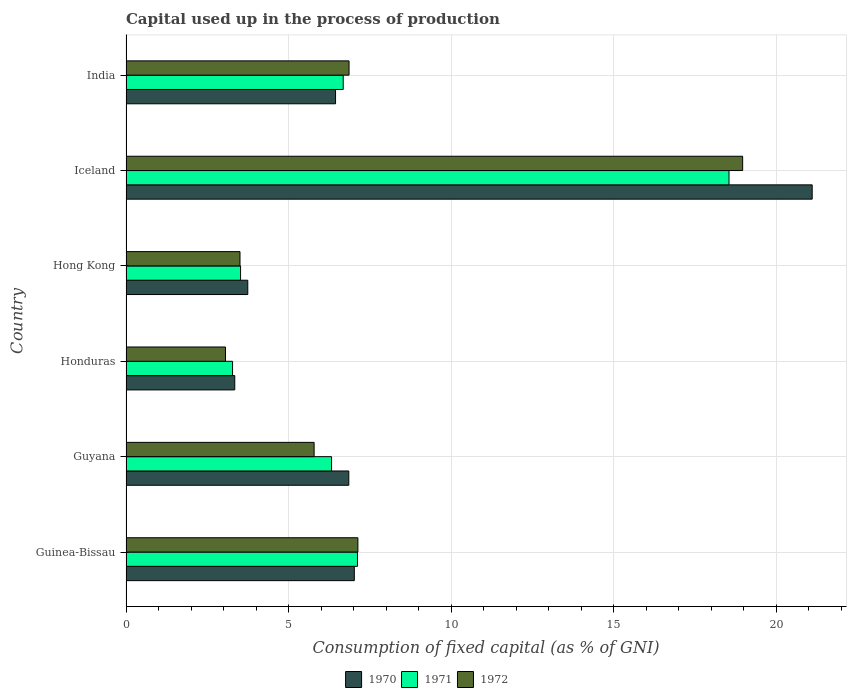How many different coloured bars are there?
Keep it short and to the point. 3. Are the number of bars per tick equal to the number of legend labels?
Keep it short and to the point. Yes. What is the label of the 1st group of bars from the top?
Ensure brevity in your answer.  India. In how many cases, is the number of bars for a given country not equal to the number of legend labels?
Make the answer very short. 0. What is the capital used up in the process of production in 1970 in Iceland?
Give a very brief answer. 21.11. Across all countries, what is the maximum capital used up in the process of production in 1972?
Provide a succinct answer. 18.97. Across all countries, what is the minimum capital used up in the process of production in 1971?
Ensure brevity in your answer.  3.28. In which country was the capital used up in the process of production in 1970 minimum?
Make the answer very short. Honduras. What is the total capital used up in the process of production in 1970 in the graph?
Ensure brevity in your answer.  48.53. What is the difference between the capital used up in the process of production in 1970 in Guyana and that in Honduras?
Provide a short and direct response. 3.51. What is the difference between the capital used up in the process of production in 1971 in Honduras and the capital used up in the process of production in 1970 in Guinea-Bissau?
Make the answer very short. -3.75. What is the average capital used up in the process of production in 1972 per country?
Provide a short and direct response. 7.55. What is the difference between the capital used up in the process of production in 1971 and capital used up in the process of production in 1970 in Guinea-Bissau?
Your answer should be very brief. 0.1. What is the ratio of the capital used up in the process of production in 1970 in Guyana to that in Iceland?
Ensure brevity in your answer.  0.32. What is the difference between the highest and the second highest capital used up in the process of production in 1972?
Keep it short and to the point. 11.84. What is the difference between the highest and the lowest capital used up in the process of production in 1972?
Make the answer very short. 15.91. In how many countries, is the capital used up in the process of production in 1971 greater than the average capital used up in the process of production in 1971 taken over all countries?
Your response must be concise. 1. Is the sum of the capital used up in the process of production in 1970 in Iceland and India greater than the maximum capital used up in the process of production in 1972 across all countries?
Your answer should be compact. Yes. What does the 3rd bar from the bottom in Hong Kong represents?
Provide a short and direct response. 1972. Is it the case that in every country, the sum of the capital used up in the process of production in 1970 and capital used up in the process of production in 1971 is greater than the capital used up in the process of production in 1972?
Keep it short and to the point. Yes. How many countries are there in the graph?
Your answer should be very brief. 6. Are the values on the major ticks of X-axis written in scientific E-notation?
Your answer should be compact. No. Does the graph contain grids?
Provide a succinct answer. Yes. How many legend labels are there?
Your response must be concise. 3. How are the legend labels stacked?
Provide a short and direct response. Horizontal. What is the title of the graph?
Keep it short and to the point. Capital used up in the process of production. Does "1966" appear as one of the legend labels in the graph?
Keep it short and to the point. No. What is the label or title of the X-axis?
Ensure brevity in your answer.  Consumption of fixed capital (as % of GNI). What is the label or title of the Y-axis?
Give a very brief answer. Country. What is the Consumption of fixed capital (as % of GNI) of 1970 in Guinea-Bissau?
Ensure brevity in your answer.  7.02. What is the Consumption of fixed capital (as % of GNI) in 1971 in Guinea-Bissau?
Offer a terse response. 7.12. What is the Consumption of fixed capital (as % of GNI) in 1972 in Guinea-Bissau?
Your answer should be very brief. 7.13. What is the Consumption of fixed capital (as % of GNI) of 1970 in Guyana?
Offer a terse response. 6.85. What is the Consumption of fixed capital (as % of GNI) of 1971 in Guyana?
Your answer should be very brief. 6.32. What is the Consumption of fixed capital (as % of GNI) of 1972 in Guyana?
Provide a short and direct response. 5.79. What is the Consumption of fixed capital (as % of GNI) in 1970 in Honduras?
Keep it short and to the point. 3.35. What is the Consumption of fixed capital (as % of GNI) of 1971 in Honduras?
Ensure brevity in your answer.  3.28. What is the Consumption of fixed capital (as % of GNI) of 1972 in Honduras?
Provide a succinct answer. 3.06. What is the Consumption of fixed capital (as % of GNI) in 1970 in Hong Kong?
Give a very brief answer. 3.75. What is the Consumption of fixed capital (as % of GNI) of 1971 in Hong Kong?
Provide a succinct answer. 3.52. What is the Consumption of fixed capital (as % of GNI) in 1972 in Hong Kong?
Offer a very short reply. 3.51. What is the Consumption of fixed capital (as % of GNI) of 1970 in Iceland?
Offer a terse response. 21.11. What is the Consumption of fixed capital (as % of GNI) in 1971 in Iceland?
Ensure brevity in your answer.  18.55. What is the Consumption of fixed capital (as % of GNI) in 1972 in Iceland?
Make the answer very short. 18.97. What is the Consumption of fixed capital (as % of GNI) in 1970 in India?
Give a very brief answer. 6.45. What is the Consumption of fixed capital (as % of GNI) of 1971 in India?
Ensure brevity in your answer.  6.68. What is the Consumption of fixed capital (as % of GNI) in 1972 in India?
Provide a succinct answer. 6.86. Across all countries, what is the maximum Consumption of fixed capital (as % of GNI) in 1970?
Make the answer very short. 21.11. Across all countries, what is the maximum Consumption of fixed capital (as % of GNI) of 1971?
Ensure brevity in your answer.  18.55. Across all countries, what is the maximum Consumption of fixed capital (as % of GNI) of 1972?
Your answer should be very brief. 18.97. Across all countries, what is the minimum Consumption of fixed capital (as % of GNI) in 1970?
Make the answer very short. 3.35. Across all countries, what is the minimum Consumption of fixed capital (as % of GNI) of 1971?
Make the answer very short. 3.28. Across all countries, what is the minimum Consumption of fixed capital (as % of GNI) of 1972?
Provide a succinct answer. 3.06. What is the total Consumption of fixed capital (as % of GNI) in 1970 in the graph?
Provide a short and direct response. 48.53. What is the total Consumption of fixed capital (as % of GNI) of 1971 in the graph?
Your answer should be very brief. 45.49. What is the total Consumption of fixed capital (as % of GNI) in 1972 in the graph?
Provide a short and direct response. 45.33. What is the difference between the Consumption of fixed capital (as % of GNI) of 1970 in Guinea-Bissau and that in Guyana?
Make the answer very short. 0.17. What is the difference between the Consumption of fixed capital (as % of GNI) in 1971 in Guinea-Bissau and that in Guyana?
Keep it short and to the point. 0.8. What is the difference between the Consumption of fixed capital (as % of GNI) of 1972 in Guinea-Bissau and that in Guyana?
Provide a succinct answer. 1.35. What is the difference between the Consumption of fixed capital (as % of GNI) of 1970 in Guinea-Bissau and that in Honduras?
Your answer should be very brief. 3.68. What is the difference between the Consumption of fixed capital (as % of GNI) of 1971 in Guinea-Bissau and that in Honduras?
Keep it short and to the point. 3.84. What is the difference between the Consumption of fixed capital (as % of GNI) of 1972 in Guinea-Bissau and that in Honduras?
Your answer should be compact. 4.07. What is the difference between the Consumption of fixed capital (as % of GNI) of 1970 in Guinea-Bissau and that in Hong Kong?
Ensure brevity in your answer.  3.28. What is the difference between the Consumption of fixed capital (as % of GNI) of 1971 in Guinea-Bissau and that in Hong Kong?
Your answer should be very brief. 3.6. What is the difference between the Consumption of fixed capital (as % of GNI) in 1972 in Guinea-Bissau and that in Hong Kong?
Give a very brief answer. 3.63. What is the difference between the Consumption of fixed capital (as % of GNI) in 1970 in Guinea-Bissau and that in Iceland?
Provide a succinct answer. -14.09. What is the difference between the Consumption of fixed capital (as % of GNI) in 1971 in Guinea-Bissau and that in Iceland?
Your answer should be compact. -11.43. What is the difference between the Consumption of fixed capital (as % of GNI) of 1972 in Guinea-Bissau and that in Iceland?
Give a very brief answer. -11.84. What is the difference between the Consumption of fixed capital (as % of GNI) of 1970 in Guinea-Bissau and that in India?
Offer a very short reply. 0.58. What is the difference between the Consumption of fixed capital (as % of GNI) of 1971 in Guinea-Bissau and that in India?
Offer a very short reply. 0.44. What is the difference between the Consumption of fixed capital (as % of GNI) in 1972 in Guinea-Bissau and that in India?
Your response must be concise. 0.27. What is the difference between the Consumption of fixed capital (as % of GNI) of 1970 in Guyana and that in Honduras?
Your answer should be very brief. 3.51. What is the difference between the Consumption of fixed capital (as % of GNI) of 1971 in Guyana and that in Honduras?
Ensure brevity in your answer.  3.05. What is the difference between the Consumption of fixed capital (as % of GNI) of 1972 in Guyana and that in Honduras?
Offer a very short reply. 2.73. What is the difference between the Consumption of fixed capital (as % of GNI) in 1970 in Guyana and that in Hong Kong?
Provide a short and direct response. 3.11. What is the difference between the Consumption of fixed capital (as % of GNI) in 1971 in Guyana and that in Hong Kong?
Your answer should be very brief. 2.8. What is the difference between the Consumption of fixed capital (as % of GNI) of 1972 in Guyana and that in Hong Kong?
Make the answer very short. 2.28. What is the difference between the Consumption of fixed capital (as % of GNI) of 1970 in Guyana and that in Iceland?
Make the answer very short. -14.26. What is the difference between the Consumption of fixed capital (as % of GNI) of 1971 in Guyana and that in Iceland?
Make the answer very short. -12.23. What is the difference between the Consumption of fixed capital (as % of GNI) in 1972 in Guyana and that in Iceland?
Offer a very short reply. -13.19. What is the difference between the Consumption of fixed capital (as % of GNI) in 1970 in Guyana and that in India?
Give a very brief answer. 0.41. What is the difference between the Consumption of fixed capital (as % of GNI) in 1971 in Guyana and that in India?
Keep it short and to the point. -0.36. What is the difference between the Consumption of fixed capital (as % of GNI) in 1972 in Guyana and that in India?
Make the answer very short. -1.08. What is the difference between the Consumption of fixed capital (as % of GNI) in 1970 in Honduras and that in Hong Kong?
Give a very brief answer. -0.4. What is the difference between the Consumption of fixed capital (as % of GNI) of 1971 in Honduras and that in Hong Kong?
Provide a short and direct response. -0.25. What is the difference between the Consumption of fixed capital (as % of GNI) in 1972 in Honduras and that in Hong Kong?
Give a very brief answer. -0.45. What is the difference between the Consumption of fixed capital (as % of GNI) in 1970 in Honduras and that in Iceland?
Offer a very short reply. -17.77. What is the difference between the Consumption of fixed capital (as % of GNI) in 1971 in Honduras and that in Iceland?
Ensure brevity in your answer.  -15.27. What is the difference between the Consumption of fixed capital (as % of GNI) of 1972 in Honduras and that in Iceland?
Provide a succinct answer. -15.91. What is the difference between the Consumption of fixed capital (as % of GNI) of 1970 in Honduras and that in India?
Offer a terse response. -3.1. What is the difference between the Consumption of fixed capital (as % of GNI) in 1971 in Honduras and that in India?
Make the answer very short. -3.4. What is the difference between the Consumption of fixed capital (as % of GNI) of 1972 in Honduras and that in India?
Keep it short and to the point. -3.8. What is the difference between the Consumption of fixed capital (as % of GNI) in 1970 in Hong Kong and that in Iceland?
Make the answer very short. -17.37. What is the difference between the Consumption of fixed capital (as % of GNI) in 1971 in Hong Kong and that in Iceland?
Offer a terse response. -15.03. What is the difference between the Consumption of fixed capital (as % of GNI) of 1972 in Hong Kong and that in Iceland?
Provide a succinct answer. -15.47. What is the difference between the Consumption of fixed capital (as % of GNI) of 1970 in Hong Kong and that in India?
Provide a short and direct response. -2.7. What is the difference between the Consumption of fixed capital (as % of GNI) in 1971 in Hong Kong and that in India?
Give a very brief answer. -3.16. What is the difference between the Consumption of fixed capital (as % of GNI) of 1972 in Hong Kong and that in India?
Give a very brief answer. -3.36. What is the difference between the Consumption of fixed capital (as % of GNI) of 1970 in Iceland and that in India?
Offer a terse response. 14.67. What is the difference between the Consumption of fixed capital (as % of GNI) of 1971 in Iceland and that in India?
Offer a terse response. 11.87. What is the difference between the Consumption of fixed capital (as % of GNI) in 1972 in Iceland and that in India?
Ensure brevity in your answer.  12.11. What is the difference between the Consumption of fixed capital (as % of GNI) in 1970 in Guinea-Bissau and the Consumption of fixed capital (as % of GNI) in 1971 in Guyana?
Keep it short and to the point. 0.7. What is the difference between the Consumption of fixed capital (as % of GNI) in 1970 in Guinea-Bissau and the Consumption of fixed capital (as % of GNI) in 1972 in Guyana?
Keep it short and to the point. 1.24. What is the difference between the Consumption of fixed capital (as % of GNI) in 1971 in Guinea-Bissau and the Consumption of fixed capital (as % of GNI) in 1972 in Guyana?
Ensure brevity in your answer.  1.33. What is the difference between the Consumption of fixed capital (as % of GNI) of 1970 in Guinea-Bissau and the Consumption of fixed capital (as % of GNI) of 1971 in Honduras?
Provide a short and direct response. 3.75. What is the difference between the Consumption of fixed capital (as % of GNI) in 1970 in Guinea-Bissau and the Consumption of fixed capital (as % of GNI) in 1972 in Honduras?
Provide a succinct answer. 3.96. What is the difference between the Consumption of fixed capital (as % of GNI) of 1971 in Guinea-Bissau and the Consumption of fixed capital (as % of GNI) of 1972 in Honduras?
Your answer should be very brief. 4.06. What is the difference between the Consumption of fixed capital (as % of GNI) in 1970 in Guinea-Bissau and the Consumption of fixed capital (as % of GNI) in 1972 in Hong Kong?
Keep it short and to the point. 3.52. What is the difference between the Consumption of fixed capital (as % of GNI) in 1971 in Guinea-Bissau and the Consumption of fixed capital (as % of GNI) in 1972 in Hong Kong?
Provide a short and direct response. 3.61. What is the difference between the Consumption of fixed capital (as % of GNI) of 1970 in Guinea-Bissau and the Consumption of fixed capital (as % of GNI) of 1971 in Iceland?
Give a very brief answer. -11.53. What is the difference between the Consumption of fixed capital (as % of GNI) of 1970 in Guinea-Bissau and the Consumption of fixed capital (as % of GNI) of 1972 in Iceland?
Your answer should be compact. -11.95. What is the difference between the Consumption of fixed capital (as % of GNI) in 1971 in Guinea-Bissau and the Consumption of fixed capital (as % of GNI) in 1972 in Iceland?
Offer a very short reply. -11.85. What is the difference between the Consumption of fixed capital (as % of GNI) of 1970 in Guinea-Bissau and the Consumption of fixed capital (as % of GNI) of 1971 in India?
Make the answer very short. 0.34. What is the difference between the Consumption of fixed capital (as % of GNI) in 1970 in Guinea-Bissau and the Consumption of fixed capital (as % of GNI) in 1972 in India?
Offer a terse response. 0.16. What is the difference between the Consumption of fixed capital (as % of GNI) in 1971 in Guinea-Bissau and the Consumption of fixed capital (as % of GNI) in 1972 in India?
Ensure brevity in your answer.  0.26. What is the difference between the Consumption of fixed capital (as % of GNI) of 1970 in Guyana and the Consumption of fixed capital (as % of GNI) of 1971 in Honduras?
Make the answer very short. 3.58. What is the difference between the Consumption of fixed capital (as % of GNI) in 1970 in Guyana and the Consumption of fixed capital (as % of GNI) in 1972 in Honduras?
Ensure brevity in your answer.  3.79. What is the difference between the Consumption of fixed capital (as % of GNI) in 1971 in Guyana and the Consumption of fixed capital (as % of GNI) in 1972 in Honduras?
Provide a short and direct response. 3.26. What is the difference between the Consumption of fixed capital (as % of GNI) in 1970 in Guyana and the Consumption of fixed capital (as % of GNI) in 1971 in Hong Kong?
Keep it short and to the point. 3.33. What is the difference between the Consumption of fixed capital (as % of GNI) in 1970 in Guyana and the Consumption of fixed capital (as % of GNI) in 1972 in Hong Kong?
Ensure brevity in your answer.  3.35. What is the difference between the Consumption of fixed capital (as % of GNI) of 1971 in Guyana and the Consumption of fixed capital (as % of GNI) of 1972 in Hong Kong?
Offer a terse response. 2.82. What is the difference between the Consumption of fixed capital (as % of GNI) of 1970 in Guyana and the Consumption of fixed capital (as % of GNI) of 1971 in Iceland?
Your response must be concise. -11.7. What is the difference between the Consumption of fixed capital (as % of GNI) in 1970 in Guyana and the Consumption of fixed capital (as % of GNI) in 1972 in Iceland?
Ensure brevity in your answer.  -12.12. What is the difference between the Consumption of fixed capital (as % of GNI) of 1971 in Guyana and the Consumption of fixed capital (as % of GNI) of 1972 in Iceland?
Offer a terse response. -12.65. What is the difference between the Consumption of fixed capital (as % of GNI) of 1970 in Guyana and the Consumption of fixed capital (as % of GNI) of 1971 in India?
Provide a short and direct response. 0.17. What is the difference between the Consumption of fixed capital (as % of GNI) of 1970 in Guyana and the Consumption of fixed capital (as % of GNI) of 1972 in India?
Your response must be concise. -0.01. What is the difference between the Consumption of fixed capital (as % of GNI) in 1971 in Guyana and the Consumption of fixed capital (as % of GNI) in 1972 in India?
Offer a terse response. -0.54. What is the difference between the Consumption of fixed capital (as % of GNI) of 1970 in Honduras and the Consumption of fixed capital (as % of GNI) of 1971 in Hong Kong?
Your answer should be compact. -0.18. What is the difference between the Consumption of fixed capital (as % of GNI) of 1970 in Honduras and the Consumption of fixed capital (as % of GNI) of 1972 in Hong Kong?
Offer a very short reply. -0.16. What is the difference between the Consumption of fixed capital (as % of GNI) in 1971 in Honduras and the Consumption of fixed capital (as % of GNI) in 1972 in Hong Kong?
Offer a very short reply. -0.23. What is the difference between the Consumption of fixed capital (as % of GNI) of 1970 in Honduras and the Consumption of fixed capital (as % of GNI) of 1971 in Iceland?
Ensure brevity in your answer.  -15.21. What is the difference between the Consumption of fixed capital (as % of GNI) of 1970 in Honduras and the Consumption of fixed capital (as % of GNI) of 1972 in Iceland?
Provide a short and direct response. -15.63. What is the difference between the Consumption of fixed capital (as % of GNI) in 1971 in Honduras and the Consumption of fixed capital (as % of GNI) in 1972 in Iceland?
Provide a succinct answer. -15.7. What is the difference between the Consumption of fixed capital (as % of GNI) in 1970 in Honduras and the Consumption of fixed capital (as % of GNI) in 1971 in India?
Provide a short and direct response. -3.34. What is the difference between the Consumption of fixed capital (as % of GNI) in 1970 in Honduras and the Consumption of fixed capital (as % of GNI) in 1972 in India?
Offer a very short reply. -3.52. What is the difference between the Consumption of fixed capital (as % of GNI) of 1971 in Honduras and the Consumption of fixed capital (as % of GNI) of 1972 in India?
Your response must be concise. -3.58. What is the difference between the Consumption of fixed capital (as % of GNI) in 1970 in Hong Kong and the Consumption of fixed capital (as % of GNI) in 1971 in Iceland?
Keep it short and to the point. -14.81. What is the difference between the Consumption of fixed capital (as % of GNI) in 1970 in Hong Kong and the Consumption of fixed capital (as % of GNI) in 1972 in Iceland?
Provide a short and direct response. -15.23. What is the difference between the Consumption of fixed capital (as % of GNI) in 1971 in Hong Kong and the Consumption of fixed capital (as % of GNI) in 1972 in Iceland?
Make the answer very short. -15.45. What is the difference between the Consumption of fixed capital (as % of GNI) in 1970 in Hong Kong and the Consumption of fixed capital (as % of GNI) in 1971 in India?
Offer a terse response. -2.94. What is the difference between the Consumption of fixed capital (as % of GNI) of 1970 in Hong Kong and the Consumption of fixed capital (as % of GNI) of 1972 in India?
Your response must be concise. -3.12. What is the difference between the Consumption of fixed capital (as % of GNI) in 1971 in Hong Kong and the Consumption of fixed capital (as % of GNI) in 1972 in India?
Offer a terse response. -3.34. What is the difference between the Consumption of fixed capital (as % of GNI) of 1970 in Iceland and the Consumption of fixed capital (as % of GNI) of 1971 in India?
Your response must be concise. 14.43. What is the difference between the Consumption of fixed capital (as % of GNI) of 1970 in Iceland and the Consumption of fixed capital (as % of GNI) of 1972 in India?
Ensure brevity in your answer.  14.25. What is the difference between the Consumption of fixed capital (as % of GNI) in 1971 in Iceland and the Consumption of fixed capital (as % of GNI) in 1972 in India?
Keep it short and to the point. 11.69. What is the average Consumption of fixed capital (as % of GNI) in 1970 per country?
Give a very brief answer. 8.09. What is the average Consumption of fixed capital (as % of GNI) of 1971 per country?
Make the answer very short. 7.58. What is the average Consumption of fixed capital (as % of GNI) of 1972 per country?
Make the answer very short. 7.55. What is the difference between the Consumption of fixed capital (as % of GNI) of 1970 and Consumption of fixed capital (as % of GNI) of 1971 in Guinea-Bissau?
Keep it short and to the point. -0.1. What is the difference between the Consumption of fixed capital (as % of GNI) in 1970 and Consumption of fixed capital (as % of GNI) in 1972 in Guinea-Bissau?
Your answer should be compact. -0.11. What is the difference between the Consumption of fixed capital (as % of GNI) of 1971 and Consumption of fixed capital (as % of GNI) of 1972 in Guinea-Bissau?
Make the answer very short. -0.01. What is the difference between the Consumption of fixed capital (as % of GNI) of 1970 and Consumption of fixed capital (as % of GNI) of 1971 in Guyana?
Your response must be concise. 0.53. What is the difference between the Consumption of fixed capital (as % of GNI) in 1970 and Consumption of fixed capital (as % of GNI) in 1972 in Guyana?
Give a very brief answer. 1.07. What is the difference between the Consumption of fixed capital (as % of GNI) in 1971 and Consumption of fixed capital (as % of GNI) in 1972 in Guyana?
Make the answer very short. 0.54. What is the difference between the Consumption of fixed capital (as % of GNI) of 1970 and Consumption of fixed capital (as % of GNI) of 1971 in Honduras?
Offer a very short reply. 0.07. What is the difference between the Consumption of fixed capital (as % of GNI) of 1970 and Consumption of fixed capital (as % of GNI) of 1972 in Honduras?
Offer a very short reply. 0.29. What is the difference between the Consumption of fixed capital (as % of GNI) in 1971 and Consumption of fixed capital (as % of GNI) in 1972 in Honduras?
Keep it short and to the point. 0.22. What is the difference between the Consumption of fixed capital (as % of GNI) in 1970 and Consumption of fixed capital (as % of GNI) in 1971 in Hong Kong?
Your answer should be compact. 0.22. What is the difference between the Consumption of fixed capital (as % of GNI) in 1970 and Consumption of fixed capital (as % of GNI) in 1972 in Hong Kong?
Provide a succinct answer. 0.24. What is the difference between the Consumption of fixed capital (as % of GNI) in 1971 and Consumption of fixed capital (as % of GNI) in 1972 in Hong Kong?
Your answer should be very brief. 0.02. What is the difference between the Consumption of fixed capital (as % of GNI) of 1970 and Consumption of fixed capital (as % of GNI) of 1971 in Iceland?
Keep it short and to the point. 2.56. What is the difference between the Consumption of fixed capital (as % of GNI) of 1970 and Consumption of fixed capital (as % of GNI) of 1972 in Iceland?
Offer a very short reply. 2.14. What is the difference between the Consumption of fixed capital (as % of GNI) of 1971 and Consumption of fixed capital (as % of GNI) of 1972 in Iceland?
Your answer should be compact. -0.42. What is the difference between the Consumption of fixed capital (as % of GNI) of 1970 and Consumption of fixed capital (as % of GNI) of 1971 in India?
Your answer should be very brief. -0.24. What is the difference between the Consumption of fixed capital (as % of GNI) of 1970 and Consumption of fixed capital (as % of GNI) of 1972 in India?
Your response must be concise. -0.42. What is the difference between the Consumption of fixed capital (as % of GNI) of 1971 and Consumption of fixed capital (as % of GNI) of 1972 in India?
Make the answer very short. -0.18. What is the ratio of the Consumption of fixed capital (as % of GNI) in 1970 in Guinea-Bissau to that in Guyana?
Provide a succinct answer. 1.02. What is the ratio of the Consumption of fixed capital (as % of GNI) in 1971 in Guinea-Bissau to that in Guyana?
Keep it short and to the point. 1.13. What is the ratio of the Consumption of fixed capital (as % of GNI) of 1972 in Guinea-Bissau to that in Guyana?
Provide a succinct answer. 1.23. What is the ratio of the Consumption of fixed capital (as % of GNI) of 1970 in Guinea-Bissau to that in Honduras?
Your answer should be compact. 2.1. What is the ratio of the Consumption of fixed capital (as % of GNI) of 1971 in Guinea-Bissau to that in Honduras?
Provide a succinct answer. 2.17. What is the ratio of the Consumption of fixed capital (as % of GNI) in 1972 in Guinea-Bissau to that in Honduras?
Keep it short and to the point. 2.33. What is the ratio of the Consumption of fixed capital (as % of GNI) in 1970 in Guinea-Bissau to that in Hong Kong?
Make the answer very short. 1.88. What is the ratio of the Consumption of fixed capital (as % of GNI) in 1971 in Guinea-Bissau to that in Hong Kong?
Your response must be concise. 2.02. What is the ratio of the Consumption of fixed capital (as % of GNI) in 1972 in Guinea-Bissau to that in Hong Kong?
Offer a very short reply. 2.03. What is the ratio of the Consumption of fixed capital (as % of GNI) of 1970 in Guinea-Bissau to that in Iceland?
Provide a short and direct response. 0.33. What is the ratio of the Consumption of fixed capital (as % of GNI) of 1971 in Guinea-Bissau to that in Iceland?
Your response must be concise. 0.38. What is the ratio of the Consumption of fixed capital (as % of GNI) in 1972 in Guinea-Bissau to that in Iceland?
Give a very brief answer. 0.38. What is the ratio of the Consumption of fixed capital (as % of GNI) in 1970 in Guinea-Bissau to that in India?
Your response must be concise. 1.09. What is the ratio of the Consumption of fixed capital (as % of GNI) of 1971 in Guinea-Bissau to that in India?
Make the answer very short. 1.07. What is the ratio of the Consumption of fixed capital (as % of GNI) in 1972 in Guinea-Bissau to that in India?
Your response must be concise. 1.04. What is the ratio of the Consumption of fixed capital (as % of GNI) of 1970 in Guyana to that in Honduras?
Your answer should be compact. 2.05. What is the ratio of the Consumption of fixed capital (as % of GNI) of 1971 in Guyana to that in Honduras?
Give a very brief answer. 1.93. What is the ratio of the Consumption of fixed capital (as % of GNI) in 1972 in Guyana to that in Honduras?
Provide a succinct answer. 1.89. What is the ratio of the Consumption of fixed capital (as % of GNI) in 1970 in Guyana to that in Hong Kong?
Make the answer very short. 1.83. What is the ratio of the Consumption of fixed capital (as % of GNI) of 1971 in Guyana to that in Hong Kong?
Keep it short and to the point. 1.79. What is the ratio of the Consumption of fixed capital (as % of GNI) in 1972 in Guyana to that in Hong Kong?
Ensure brevity in your answer.  1.65. What is the ratio of the Consumption of fixed capital (as % of GNI) of 1970 in Guyana to that in Iceland?
Your response must be concise. 0.32. What is the ratio of the Consumption of fixed capital (as % of GNI) in 1971 in Guyana to that in Iceland?
Your answer should be very brief. 0.34. What is the ratio of the Consumption of fixed capital (as % of GNI) of 1972 in Guyana to that in Iceland?
Provide a short and direct response. 0.3. What is the ratio of the Consumption of fixed capital (as % of GNI) in 1970 in Guyana to that in India?
Offer a very short reply. 1.06. What is the ratio of the Consumption of fixed capital (as % of GNI) in 1971 in Guyana to that in India?
Provide a short and direct response. 0.95. What is the ratio of the Consumption of fixed capital (as % of GNI) of 1972 in Guyana to that in India?
Keep it short and to the point. 0.84. What is the ratio of the Consumption of fixed capital (as % of GNI) in 1970 in Honduras to that in Hong Kong?
Provide a succinct answer. 0.89. What is the ratio of the Consumption of fixed capital (as % of GNI) of 1971 in Honduras to that in Hong Kong?
Offer a very short reply. 0.93. What is the ratio of the Consumption of fixed capital (as % of GNI) of 1972 in Honduras to that in Hong Kong?
Provide a short and direct response. 0.87. What is the ratio of the Consumption of fixed capital (as % of GNI) in 1970 in Honduras to that in Iceland?
Offer a terse response. 0.16. What is the ratio of the Consumption of fixed capital (as % of GNI) of 1971 in Honduras to that in Iceland?
Make the answer very short. 0.18. What is the ratio of the Consumption of fixed capital (as % of GNI) in 1972 in Honduras to that in Iceland?
Make the answer very short. 0.16. What is the ratio of the Consumption of fixed capital (as % of GNI) of 1970 in Honduras to that in India?
Offer a terse response. 0.52. What is the ratio of the Consumption of fixed capital (as % of GNI) in 1971 in Honduras to that in India?
Give a very brief answer. 0.49. What is the ratio of the Consumption of fixed capital (as % of GNI) in 1972 in Honduras to that in India?
Your response must be concise. 0.45. What is the ratio of the Consumption of fixed capital (as % of GNI) of 1970 in Hong Kong to that in Iceland?
Ensure brevity in your answer.  0.18. What is the ratio of the Consumption of fixed capital (as % of GNI) of 1971 in Hong Kong to that in Iceland?
Keep it short and to the point. 0.19. What is the ratio of the Consumption of fixed capital (as % of GNI) of 1972 in Hong Kong to that in Iceland?
Offer a very short reply. 0.18. What is the ratio of the Consumption of fixed capital (as % of GNI) of 1970 in Hong Kong to that in India?
Offer a very short reply. 0.58. What is the ratio of the Consumption of fixed capital (as % of GNI) of 1971 in Hong Kong to that in India?
Provide a succinct answer. 0.53. What is the ratio of the Consumption of fixed capital (as % of GNI) in 1972 in Hong Kong to that in India?
Your response must be concise. 0.51. What is the ratio of the Consumption of fixed capital (as % of GNI) of 1970 in Iceland to that in India?
Keep it short and to the point. 3.27. What is the ratio of the Consumption of fixed capital (as % of GNI) of 1971 in Iceland to that in India?
Keep it short and to the point. 2.78. What is the ratio of the Consumption of fixed capital (as % of GNI) in 1972 in Iceland to that in India?
Offer a very short reply. 2.76. What is the difference between the highest and the second highest Consumption of fixed capital (as % of GNI) in 1970?
Ensure brevity in your answer.  14.09. What is the difference between the highest and the second highest Consumption of fixed capital (as % of GNI) in 1971?
Make the answer very short. 11.43. What is the difference between the highest and the second highest Consumption of fixed capital (as % of GNI) in 1972?
Offer a very short reply. 11.84. What is the difference between the highest and the lowest Consumption of fixed capital (as % of GNI) of 1970?
Offer a terse response. 17.77. What is the difference between the highest and the lowest Consumption of fixed capital (as % of GNI) of 1971?
Keep it short and to the point. 15.27. What is the difference between the highest and the lowest Consumption of fixed capital (as % of GNI) in 1972?
Provide a short and direct response. 15.91. 